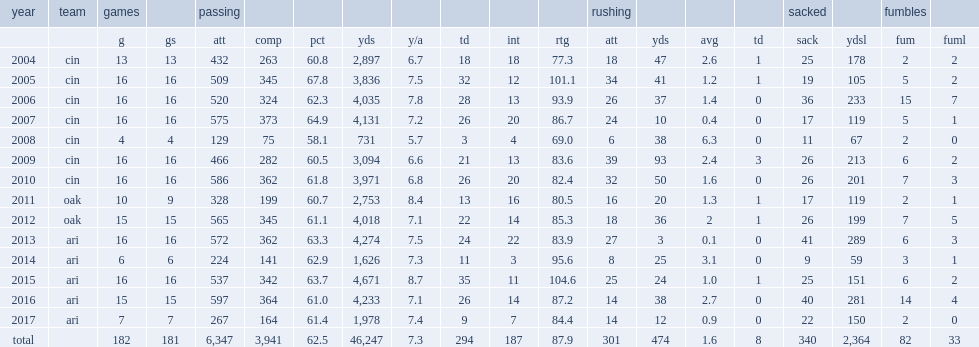How many interceotions did carson palmer get in 2004? 18.0. 